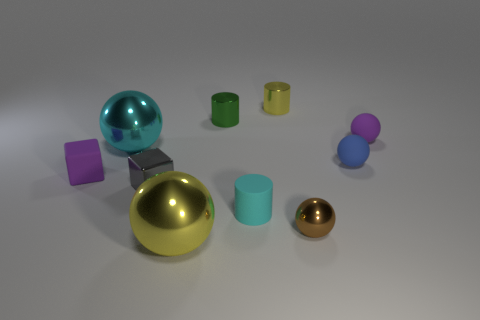Subtract all cyan cylinders. How many cylinders are left? 2 Subtract 3 balls. How many balls are left? 2 Subtract all blue balls. How many balls are left? 4 Subtract all blocks. How many objects are left? 8 Subtract all brown spheres. How many cyan blocks are left? 0 Add 7 gray metal objects. How many gray metal objects are left? 8 Add 10 large red matte blocks. How many large red matte blocks exist? 10 Subtract 0 red blocks. How many objects are left? 10 Subtract all blue cylinders. Subtract all cyan blocks. How many cylinders are left? 3 Subtract all small green metal objects. Subtract all small purple cubes. How many objects are left? 8 